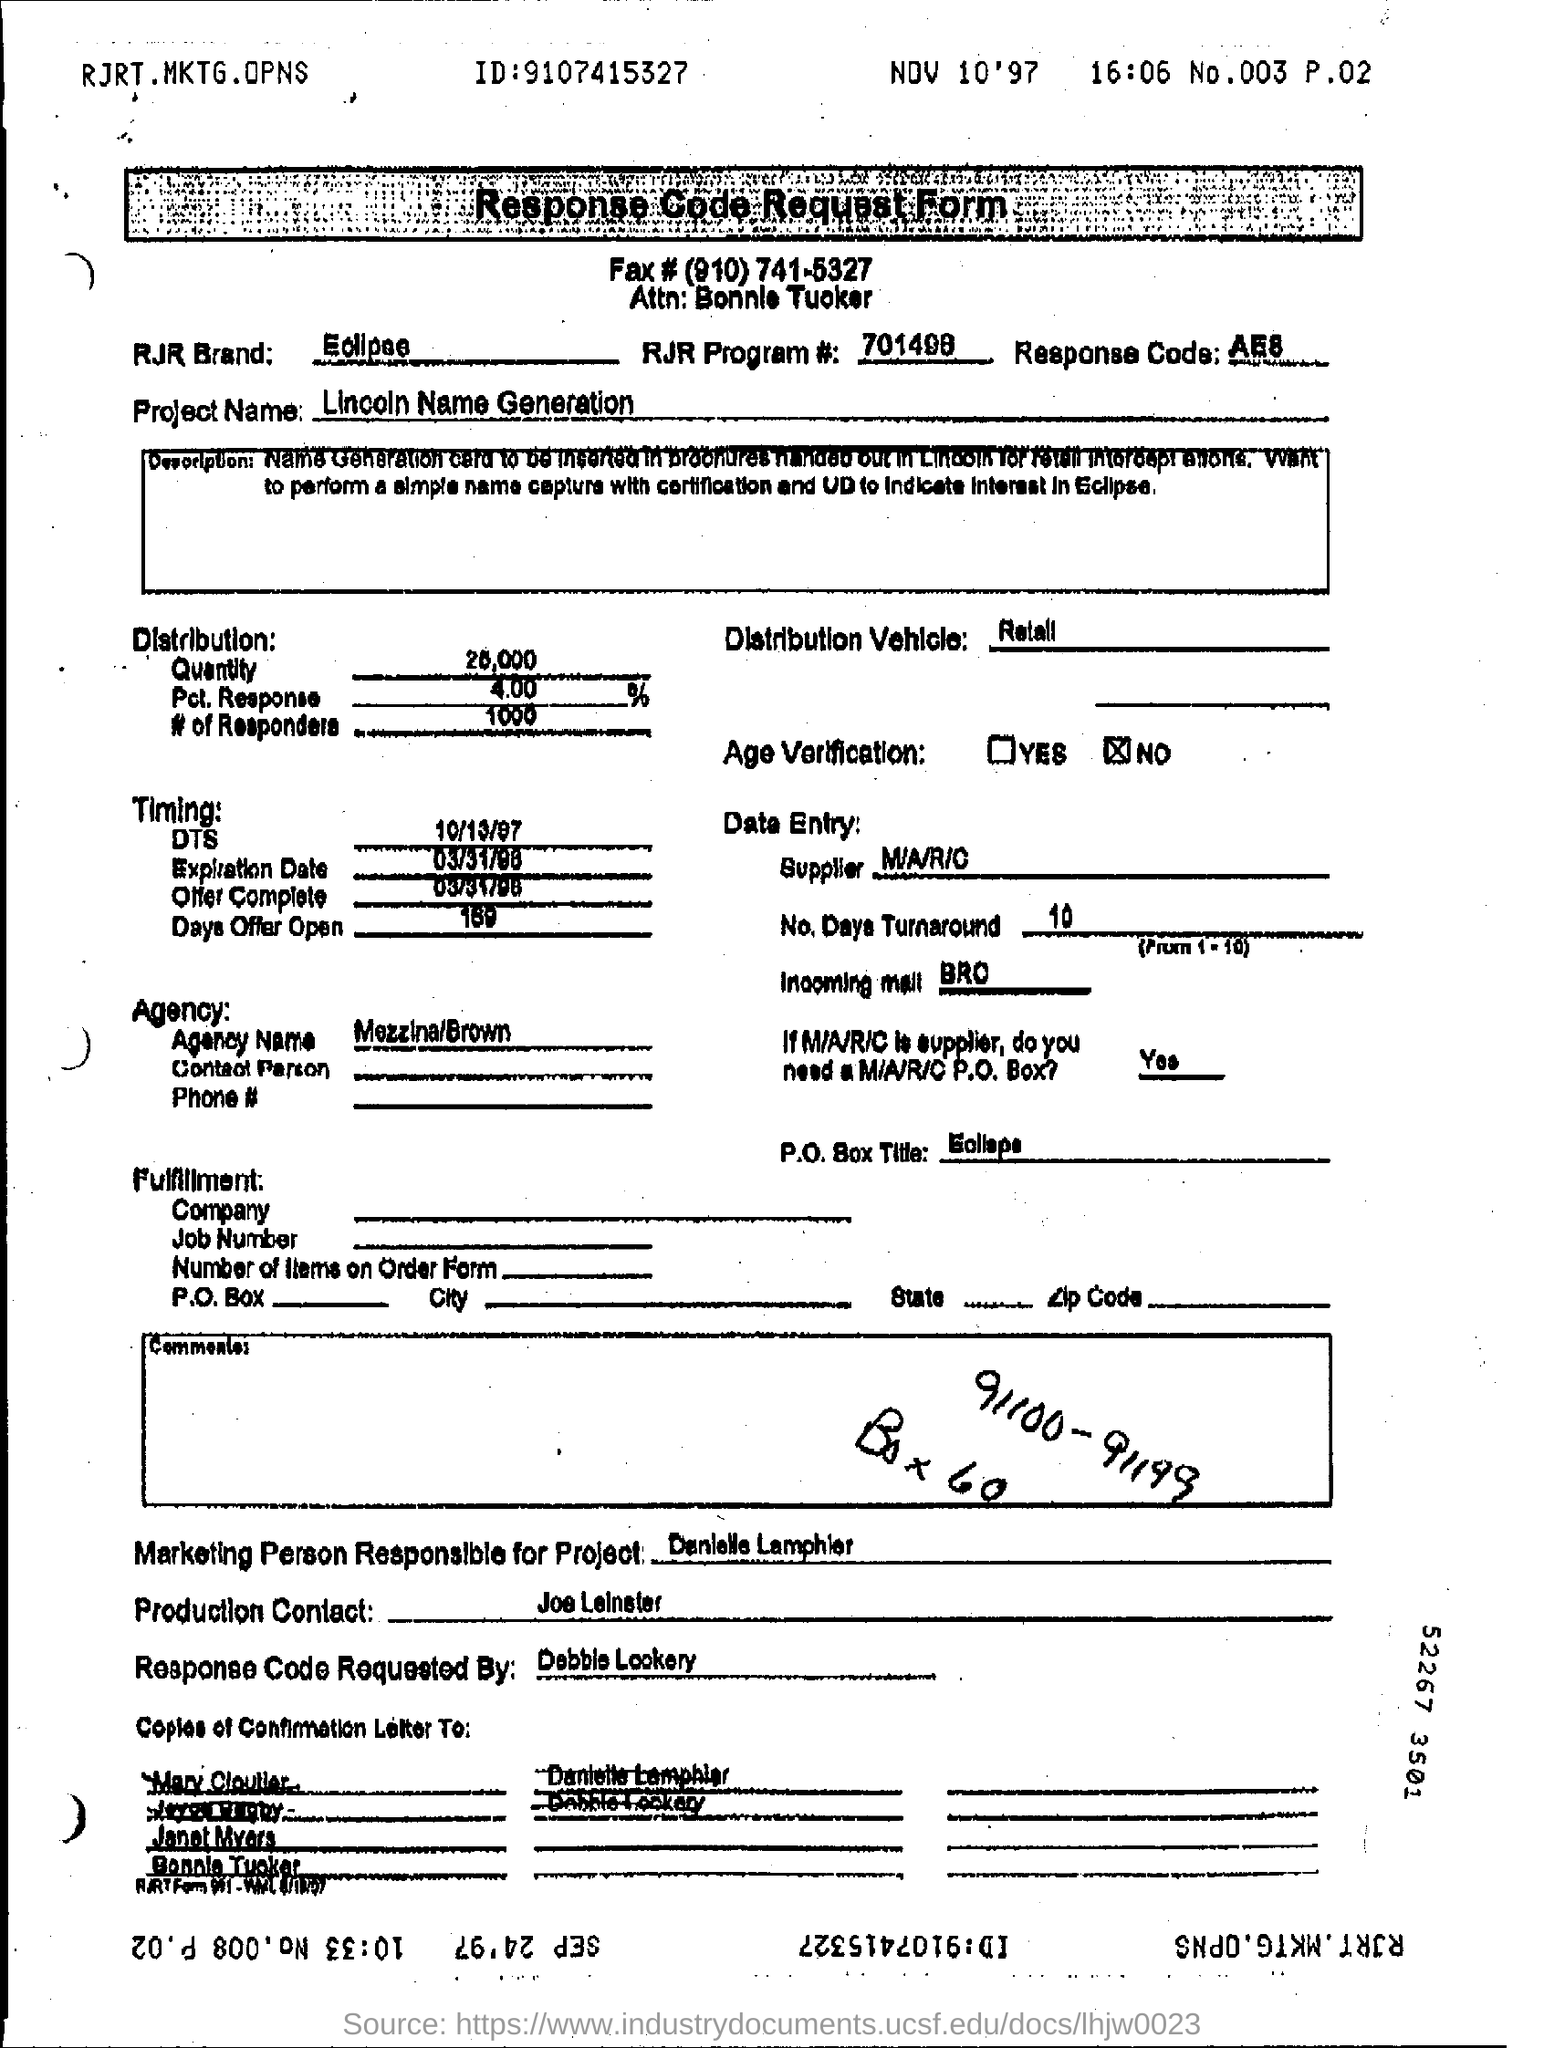Specify some key components in this picture. What is the unique identifier specified in the header? It is 9107415327 and... 